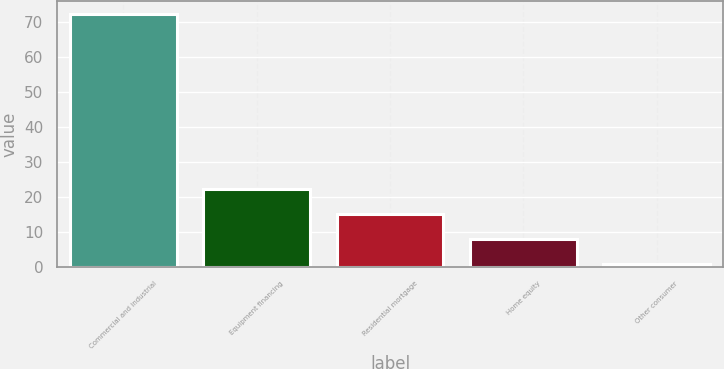Convert chart to OTSL. <chart><loc_0><loc_0><loc_500><loc_500><bar_chart><fcel>Commercial and industrial<fcel>Equipment financing<fcel>Residential mortgage<fcel>Home equity<fcel>Other consumer<nl><fcel>72.5<fcel>22.45<fcel>15.3<fcel>8.15<fcel>1<nl></chart> 